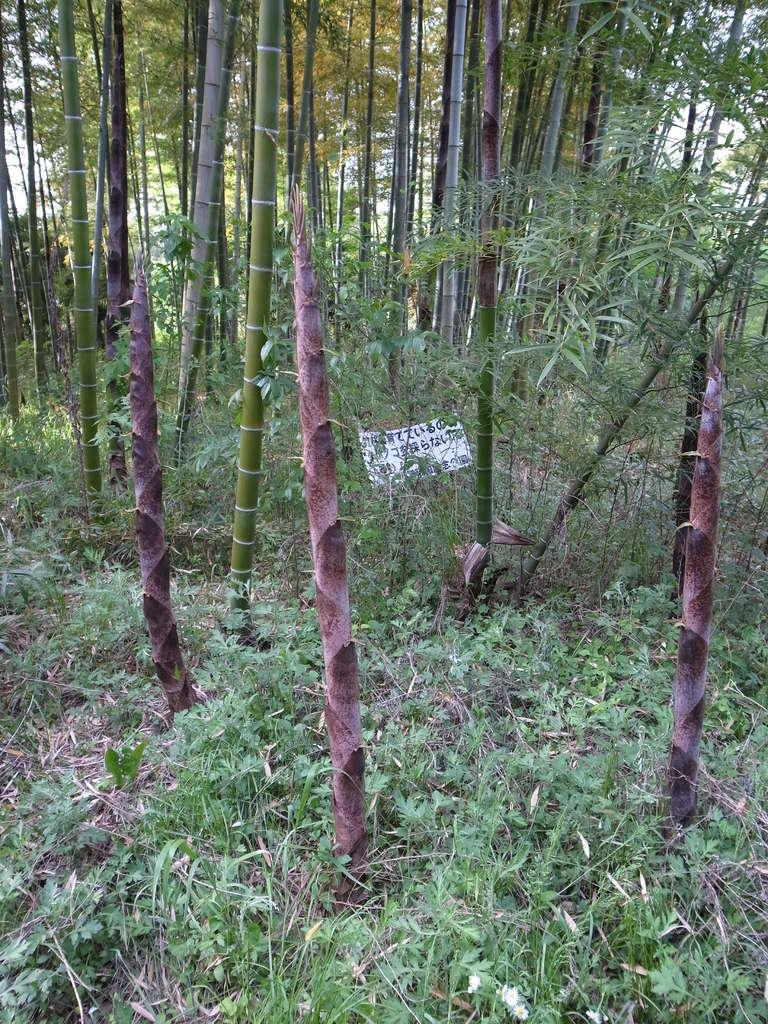What type of vegetation is present in the image? There is grass and plants in the image. What can be seen in the background of the image? There are trees in the background of the image. What is located between the trees? There is a board between the trees. How many brothers are playing in the shade of the trees in the image? There are no people, let alone brothers, present in the image. 